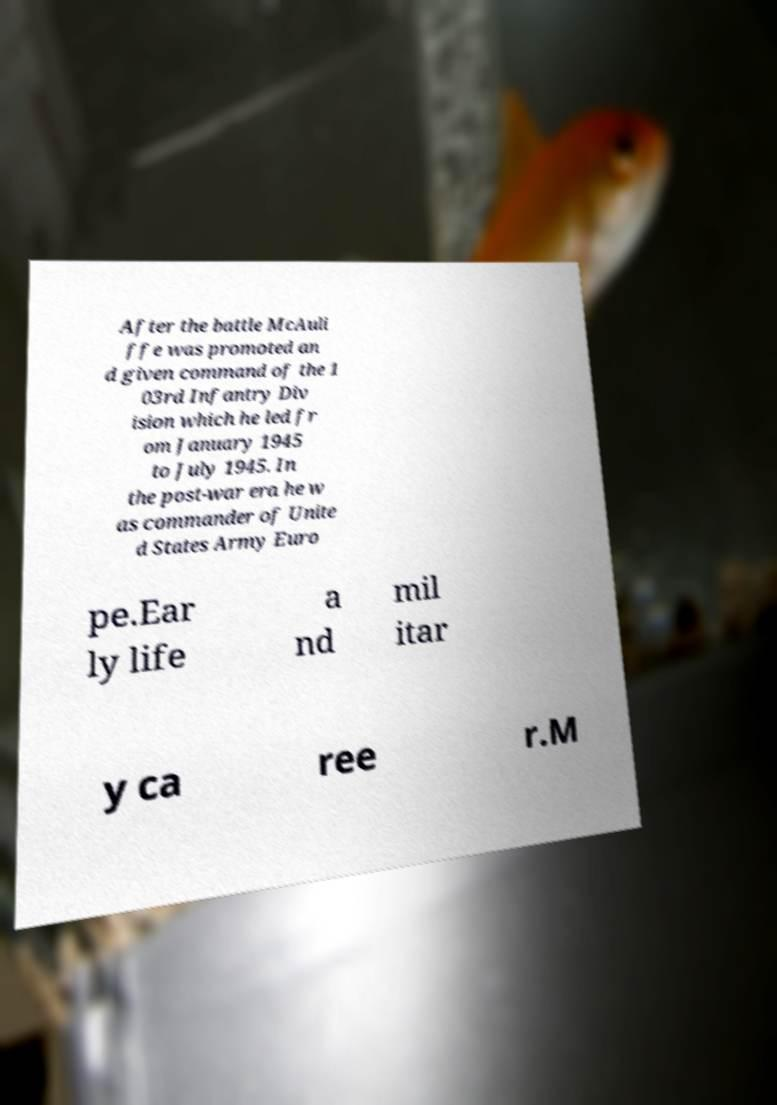There's text embedded in this image that I need extracted. Can you transcribe it verbatim? After the battle McAuli ffe was promoted an d given command of the 1 03rd Infantry Div ision which he led fr om January 1945 to July 1945. In the post-war era he w as commander of Unite d States Army Euro pe.Ear ly life a nd mil itar y ca ree r.M 